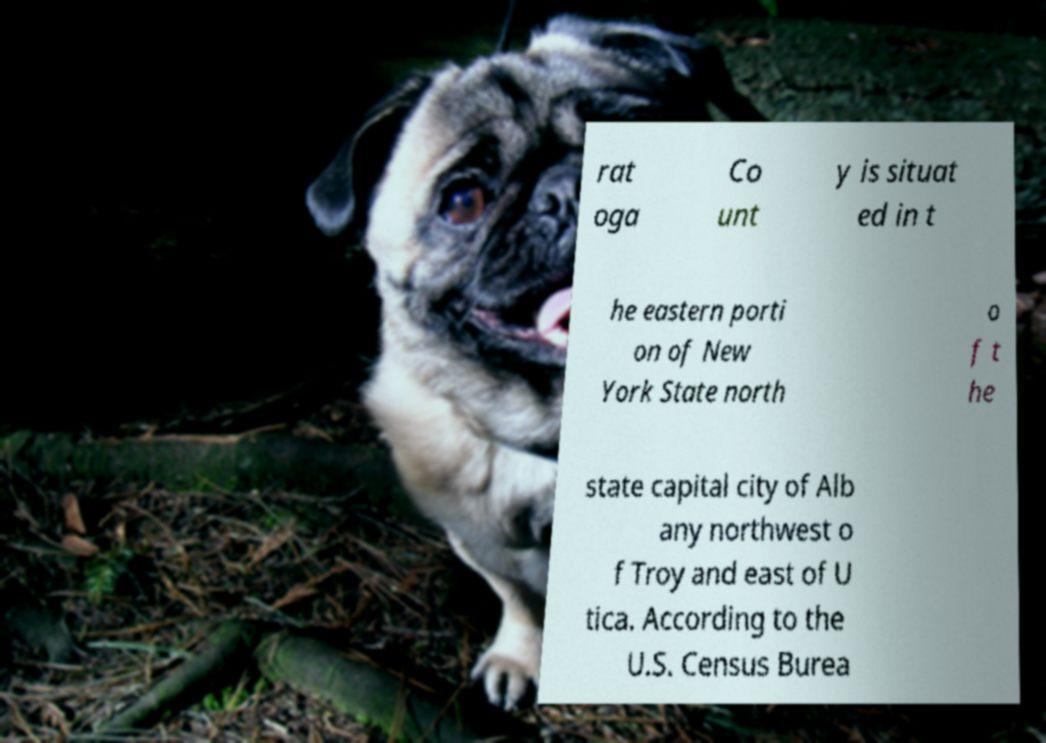Can you read and provide the text displayed in the image?This photo seems to have some interesting text. Can you extract and type it out for me? rat oga Co unt y is situat ed in t he eastern porti on of New York State north o f t he state capital city of Alb any northwest o f Troy and east of U tica. According to the U.S. Census Burea 